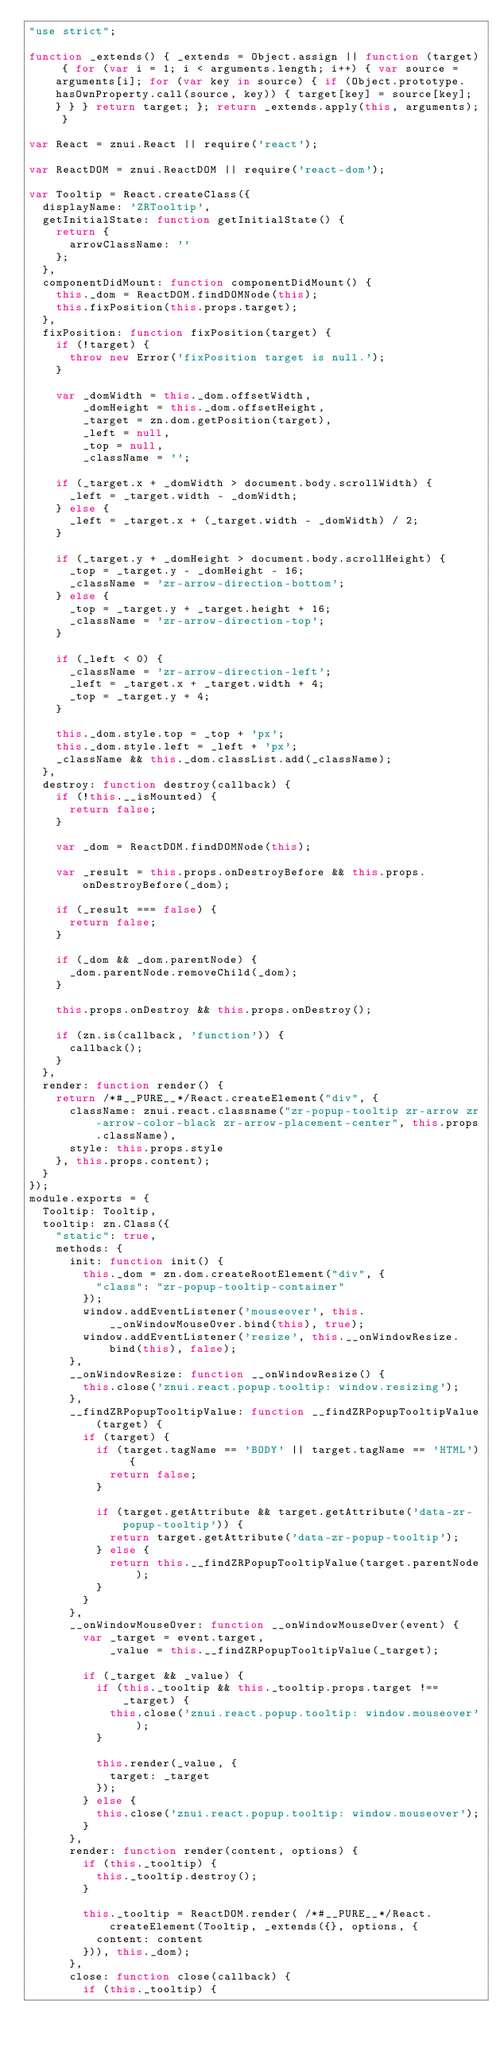Convert code to text. <code><loc_0><loc_0><loc_500><loc_500><_JavaScript_>"use strict";

function _extends() { _extends = Object.assign || function (target) { for (var i = 1; i < arguments.length; i++) { var source = arguments[i]; for (var key in source) { if (Object.prototype.hasOwnProperty.call(source, key)) { target[key] = source[key]; } } } return target; }; return _extends.apply(this, arguments); }

var React = znui.React || require('react');

var ReactDOM = znui.ReactDOM || require('react-dom');

var Tooltip = React.createClass({
  displayName: 'ZRTooltip',
  getInitialState: function getInitialState() {
    return {
      arrowClassName: ''
    };
  },
  componentDidMount: function componentDidMount() {
    this._dom = ReactDOM.findDOMNode(this);
    this.fixPosition(this.props.target);
  },
  fixPosition: function fixPosition(target) {
    if (!target) {
      throw new Error('fixPosition target is null.');
    }

    var _domWidth = this._dom.offsetWidth,
        _domHeight = this._dom.offsetHeight,
        _target = zn.dom.getPosition(target),
        _left = null,
        _top = null,
        _className = '';

    if (_target.x + _domWidth > document.body.scrollWidth) {
      _left = _target.width - _domWidth;
    } else {
      _left = _target.x + (_target.width - _domWidth) / 2;
    }

    if (_target.y + _domHeight > document.body.scrollHeight) {
      _top = _target.y - _domHeight - 16;
      _className = 'zr-arrow-direction-bottom';
    } else {
      _top = _target.y + _target.height + 16;
      _className = 'zr-arrow-direction-top';
    }

    if (_left < 0) {
      _className = 'zr-arrow-direction-left';
      _left = _target.x + _target.width + 4;
      _top = _target.y + 4;
    }

    this._dom.style.top = _top + 'px';
    this._dom.style.left = _left + 'px';
    _className && this._dom.classList.add(_className);
  },
  destroy: function destroy(callback) {
    if (!this.__isMounted) {
      return false;
    }

    var _dom = ReactDOM.findDOMNode(this);

    var _result = this.props.onDestroyBefore && this.props.onDestroyBefore(_dom);

    if (_result === false) {
      return false;
    }

    if (_dom && _dom.parentNode) {
      _dom.parentNode.removeChild(_dom);
    }

    this.props.onDestroy && this.props.onDestroy();

    if (zn.is(callback, 'function')) {
      callback();
    }
  },
  render: function render() {
    return /*#__PURE__*/React.createElement("div", {
      className: znui.react.classname("zr-popup-tooltip zr-arrow zr-arrow-color-black zr-arrow-placement-center", this.props.className),
      style: this.props.style
    }, this.props.content);
  }
});
module.exports = {
  Tooltip: Tooltip,
  tooltip: zn.Class({
    "static": true,
    methods: {
      init: function init() {
        this._dom = zn.dom.createRootElement("div", {
          "class": "zr-popup-tooltip-container"
        });
        window.addEventListener('mouseover', this.__onWindowMouseOver.bind(this), true);
        window.addEventListener('resize', this.__onWindowResize.bind(this), false);
      },
      __onWindowResize: function __onWindowResize() {
        this.close('znui.react.popup.tooltip: window.resizing');
      },
      __findZRPopupTooltipValue: function __findZRPopupTooltipValue(target) {
        if (target) {
          if (target.tagName == 'BODY' || target.tagName == 'HTML') {
            return false;
          }

          if (target.getAttribute && target.getAttribute('data-zr-popup-tooltip')) {
            return target.getAttribute('data-zr-popup-tooltip');
          } else {
            return this.__findZRPopupTooltipValue(target.parentNode);
          }
        }
      },
      __onWindowMouseOver: function __onWindowMouseOver(event) {
        var _target = event.target,
            _value = this.__findZRPopupTooltipValue(_target);

        if (_target && _value) {
          if (this._tooltip && this._tooltip.props.target !== _target) {
            this.close('znui.react.popup.tooltip: window.mouseover');
          }

          this.render(_value, {
            target: _target
          });
        } else {
          this.close('znui.react.popup.tooltip: window.mouseover');
        }
      },
      render: function render(content, options) {
        if (this._tooltip) {
          this._tooltip.destroy();
        }

        this._tooltip = ReactDOM.render( /*#__PURE__*/React.createElement(Tooltip, _extends({}, options, {
          content: content
        })), this._dom);
      },
      close: function close(callback) {
        if (this._tooltip) {</code> 